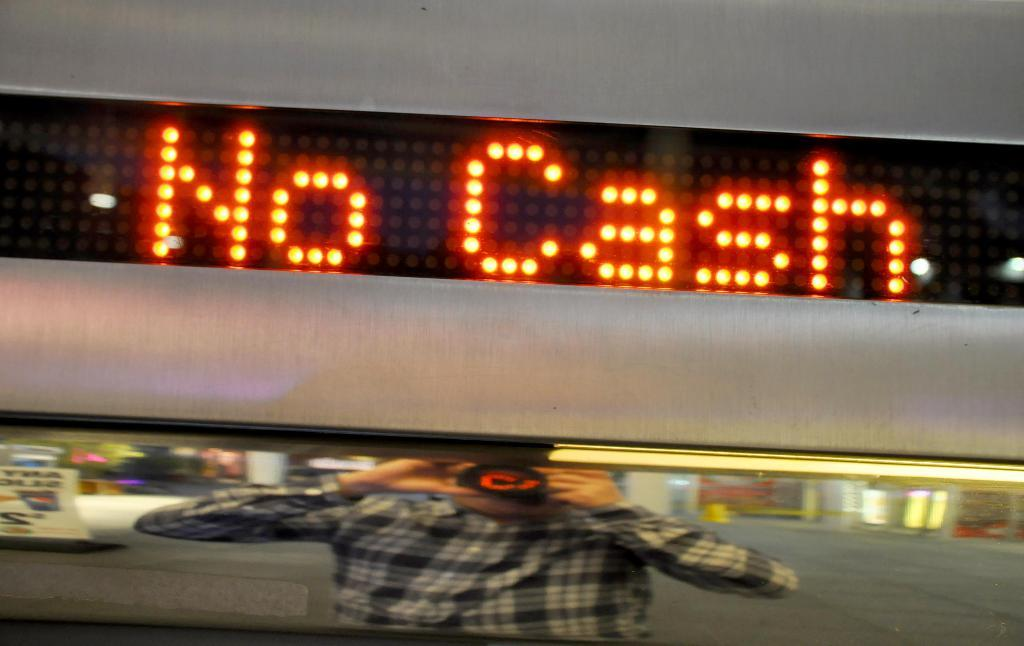<image>
Share a concise interpretation of the image provided. A sign on the wall reads "NO CASH" in bright orange letters 